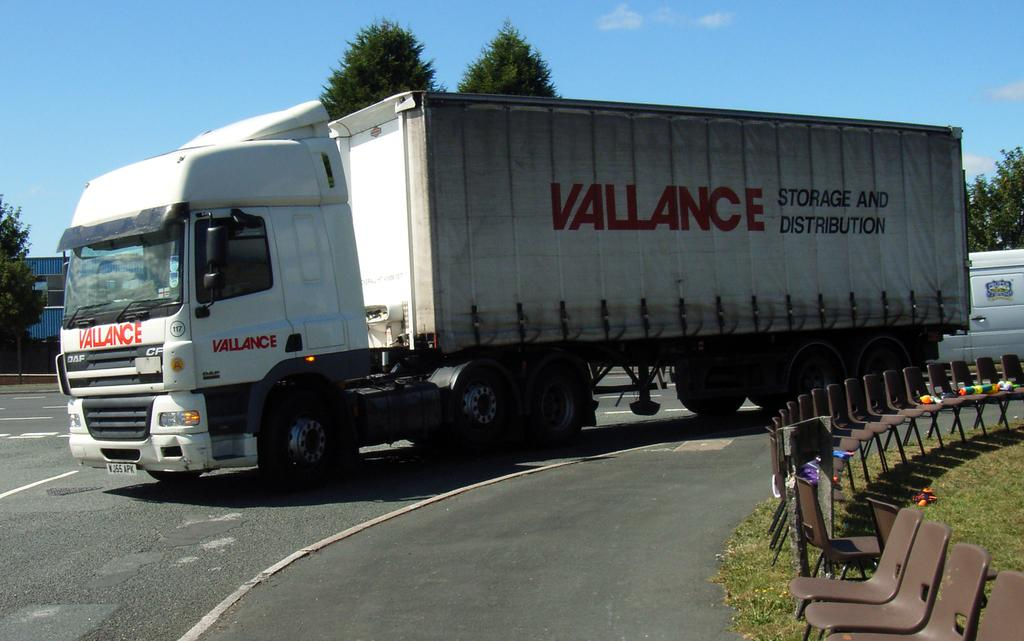What type of vehicle or truck is in the image? There is a vehicle or a truck in the image, but the specific type is not mentioned. Where is the vehicle or truck located? The vehicle or truck is on a road in the image. What other objects or items can be seen on the grass in the image? There are chairs and toys on the grass in the image. What can be seen in the background of the image? The sky and trees are visible in the background of the image. What type of meal is being prepared on the grass in the image? There is no meal being prepared in the image; it features a vehicle or truck on a road, chairs and toys on the grass, and a background with sky and trees. 